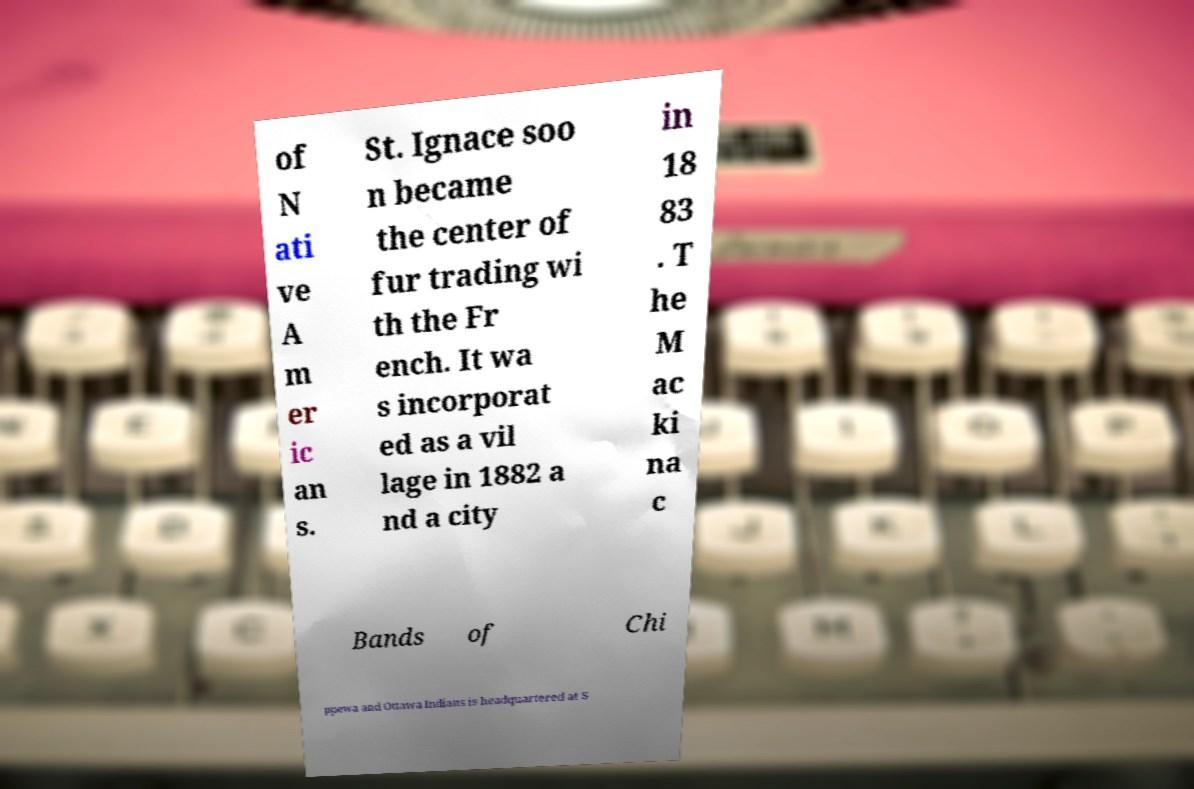Please read and relay the text visible in this image. What does it say? of N ati ve A m er ic an s. St. Ignace soo n became the center of fur trading wi th the Fr ench. It wa s incorporat ed as a vil lage in 1882 a nd a city in 18 83 . T he M ac ki na c Bands of Chi ppewa and Ottawa Indians is headquartered at S 